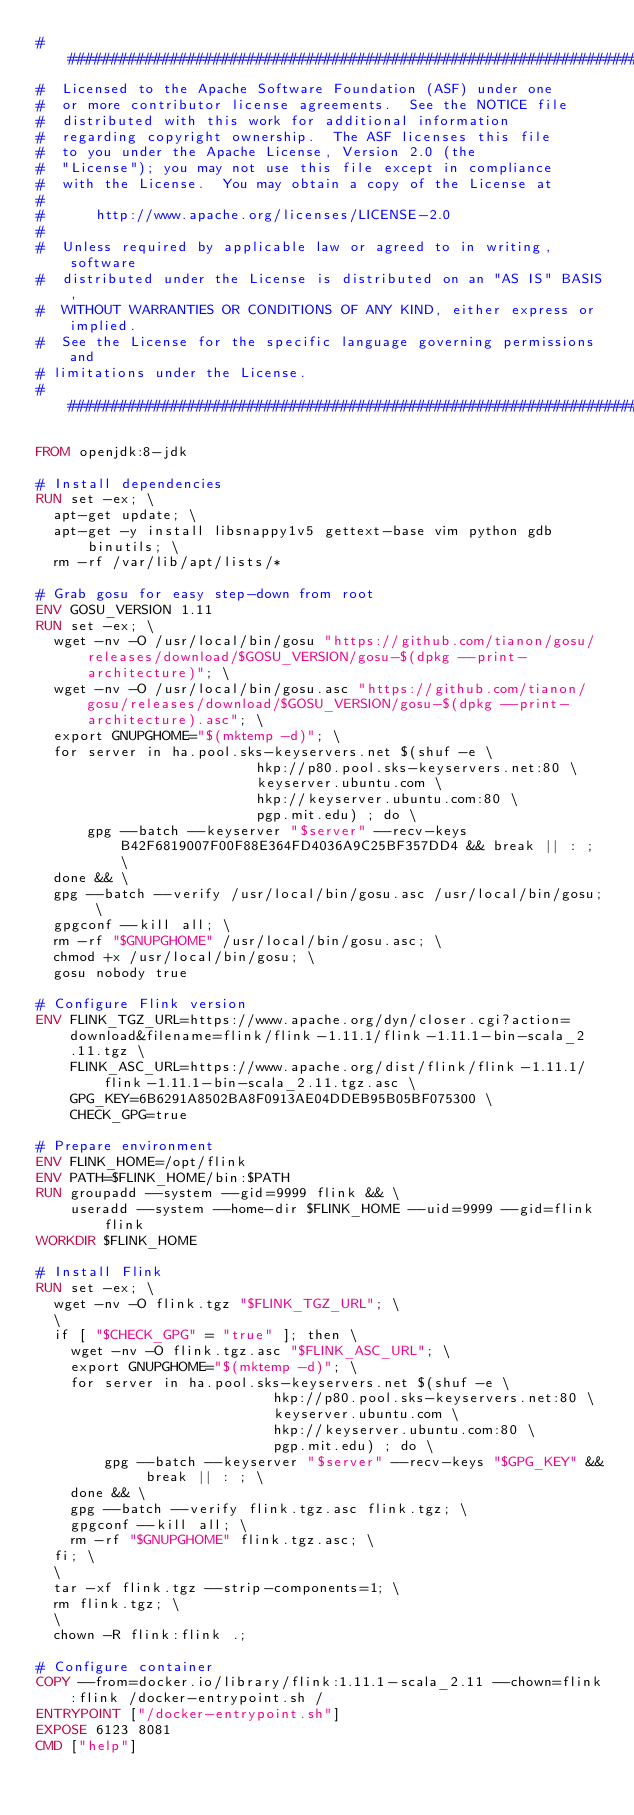<code> <loc_0><loc_0><loc_500><loc_500><_Dockerfile_>###############################################################################
#  Licensed to the Apache Software Foundation (ASF) under one
#  or more contributor license agreements.  See the NOTICE file
#  distributed with this work for additional information
#  regarding copyright ownership.  The ASF licenses this file
#  to you under the Apache License, Version 2.0 (the
#  "License"); you may not use this file except in compliance
#  with the License.  You may obtain a copy of the License at
#
#      http://www.apache.org/licenses/LICENSE-2.0
#
#  Unless required by applicable law or agreed to in writing, software
#  distributed under the License is distributed on an "AS IS" BASIS,
#  WITHOUT WARRANTIES OR CONDITIONS OF ANY KIND, either express or implied.
#  See the License for the specific language governing permissions and
# limitations under the License.
###############################################################################

FROM openjdk:8-jdk

# Install dependencies
RUN set -ex; \
  apt-get update; \
  apt-get -y install libsnappy1v5 gettext-base vim python gdb binutils; \
  rm -rf /var/lib/apt/lists/*

# Grab gosu for easy step-down from root
ENV GOSU_VERSION 1.11
RUN set -ex; \
  wget -nv -O /usr/local/bin/gosu "https://github.com/tianon/gosu/releases/download/$GOSU_VERSION/gosu-$(dpkg --print-architecture)"; \
  wget -nv -O /usr/local/bin/gosu.asc "https://github.com/tianon/gosu/releases/download/$GOSU_VERSION/gosu-$(dpkg --print-architecture).asc"; \
  export GNUPGHOME="$(mktemp -d)"; \
  for server in ha.pool.sks-keyservers.net $(shuf -e \
                          hkp://p80.pool.sks-keyservers.net:80 \
                          keyserver.ubuntu.com \
                          hkp://keyserver.ubuntu.com:80 \
                          pgp.mit.edu) ; do \
      gpg --batch --keyserver "$server" --recv-keys B42F6819007F00F88E364FD4036A9C25BF357DD4 && break || : ; \
  done && \
  gpg --batch --verify /usr/local/bin/gosu.asc /usr/local/bin/gosu; \
  gpgconf --kill all; \
  rm -rf "$GNUPGHOME" /usr/local/bin/gosu.asc; \
  chmod +x /usr/local/bin/gosu; \
  gosu nobody true

# Configure Flink version
ENV FLINK_TGZ_URL=https://www.apache.org/dyn/closer.cgi?action=download&filename=flink/flink-1.11.1/flink-1.11.1-bin-scala_2.11.tgz \
    FLINK_ASC_URL=https://www.apache.org/dist/flink/flink-1.11.1/flink-1.11.1-bin-scala_2.11.tgz.asc \
    GPG_KEY=6B6291A8502BA8F0913AE04DDEB95B05BF075300 \
    CHECK_GPG=true

# Prepare environment
ENV FLINK_HOME=/opt/flink
ENV PATH=$FLINK_HOME/bin:$PATH
RUN groupadd --system --gid=9999 flink && \
    useradd --system --home-dir $FLINK_HOME --uid=9999 --gid=flink flink
WORKDIR $FLINK_HOME

# Install Flink
RUN set -ex; \
  wget -nv -O flink.tgz "$FLINK_TGZ_URL"; \
  \
  if [ "$CHECK_GPG" = "true" ]; then \
    wget -nv -O flink.tgz.asc "$FLINK_ASC_URL"; \
    export GNUPGHOME="$(mktemp -d)"; \
    for server in ha.pool.sks-keyservers.net $(shuf -e \
                            hkp://p80.pool.sks-keyservers.net:80 \
                            keyserver.ubuntu.com \
                            hkp://keyserver.ubuntu.com:80 \
                            pgp.mit.edu) ; do \
        gpg --batch --keyserver "$server" --recv-keys "$GPG_KEY" && break || : ; \
    done && \
    gpg --batch --verify flink.tgz.asc flink.tgz; \
    gpgconf --kill all; \
    rm -rf "$GNUPGHOME" flink.tgz.asc; \
  fi; \
  \
  tar -xf flink.tgz --strip-components=1; \
  rm flink.tgz; \
  \
  chown -R flink:flink .;

# Configure container
COPY --from=docker.io/library/flink:1.11.1-scala_2.11 --chown=flink:flink /docker-entrypoint.sh /
ENTRYPOINT ["/docker-entrypoint.sh"]
EXPOSE 6123 8081
CMD ["help"]
</code> 